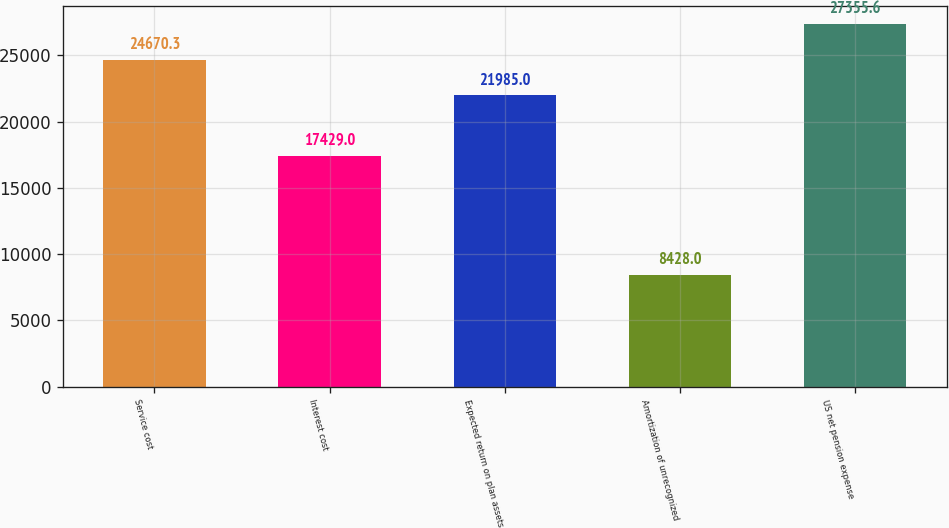Convert chart to OTSL. <chart><loc_0><loc_0><loc_500><loc_500><bar_chart><fcel>Service cost<fcel>Interest cost<fcel>Expected return on plan assets<fcel>Amortization of unrecognized<fcel>US net pension expense<nl><fcel>24670.3<fcel>17429<fcel>21985<fcel>8428<fcel>27355.6<nl></chart> 